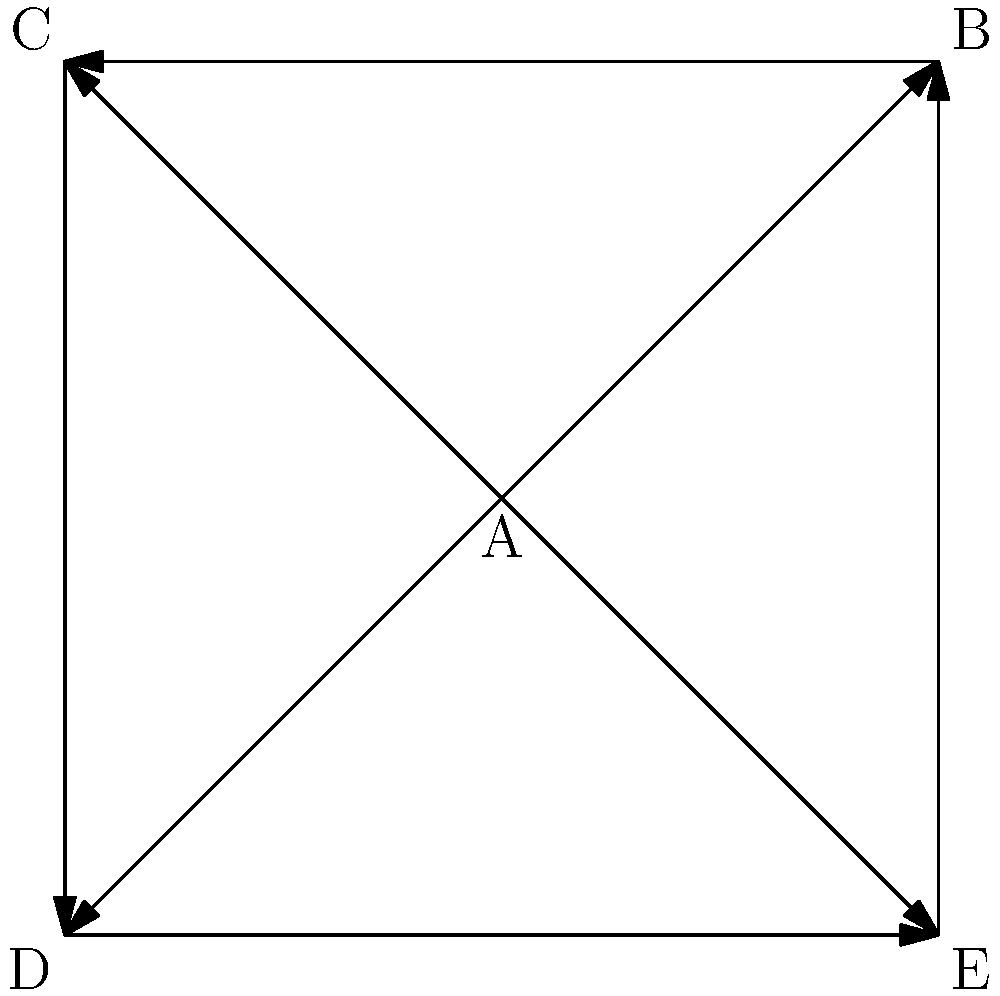In the drug interaction network shown above, vertices represent different drugs, and directed edges represent interactions between drugs. If we consider the out-degree of a vertex to represent the number of drugs it interacts with, which drug(s) have the highest potential for drug-drug interactions based on their out-degree? To answer this question, we need to analyze the out-degree of each vertex in the graph:

1. Vertex A (center):
   Out-degree = 4 (edges to B, C, D, and E)

2. Vertex B (top right):
   Out-degree = 1 (edge to C)

3. Vertex C (top left):
   Out-degree = 1 (edge to D)

4. Vertex D (bottom left):
   Out-degree = 1 (edge to E)

5. Vertex E (bottom right):
   Out-degree = 1 (edge to B)

The out-degree of a vertex in a directed graph represents the number of edges pointing away from that vertex. In this context, it indicates the number of other drugs that a particular drug interacts with.

Drug A has the highest out-degree (4), meaning it interacts with the most other drugs in the network. This suggests that Drug A has the highest potential for drug-drug interactions.

All other drugs (B, C, D, and E) have an out-degree of 1, indicating they each interact with only one other drug in the network.
Answer: Drug A 